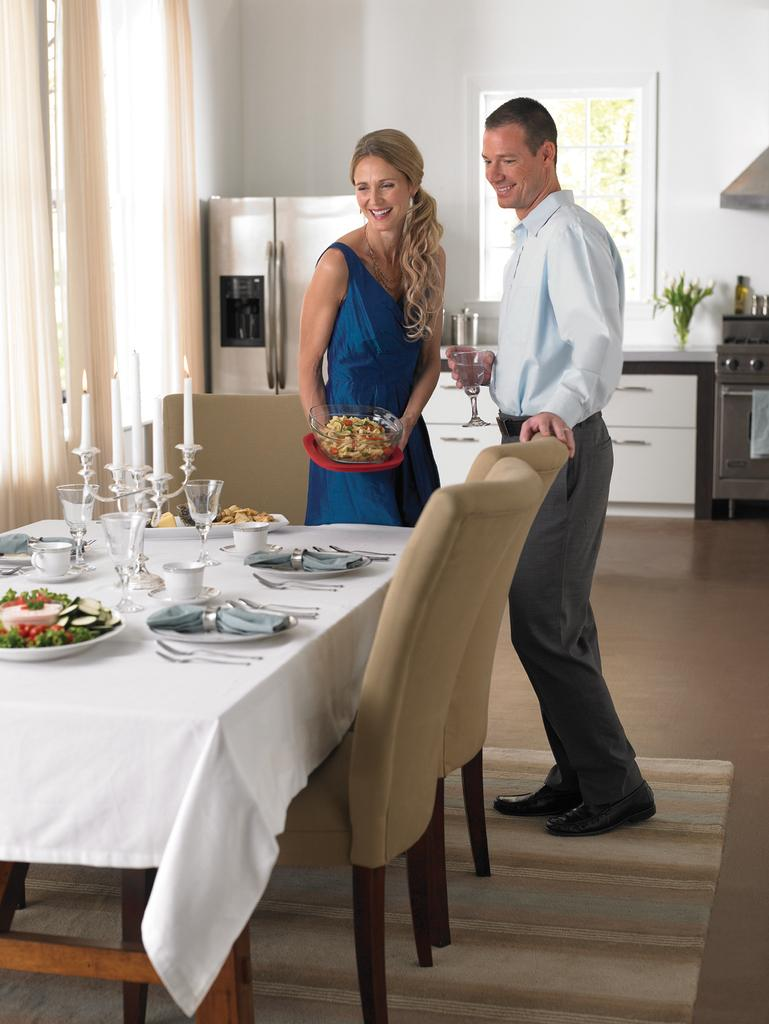How many people are in the image? There are two persons standing and smiling in the image. What is the primary object in the background of the image? There is a dining table in the image. What is placed on the dining table? There are plates and objects on the dining table. What type of window treatment is present in the image? There is a curtain in the image. What architectural feature is visible in the image? There is a window in the image. What is the history of the hobbies of the persons in the image? There is no information about the history of the hobbies of the persons in the image. How many steps are visible in the image? There are no steps visible in the image. 